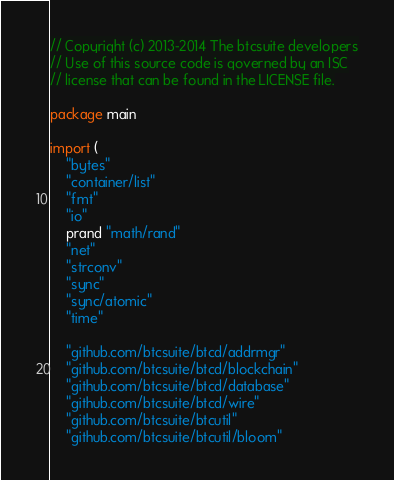Convert code to text. <code><loc_0><loc_0><loc_500><loc_500><_Go_>// Copyright (c) 2013-2014 The btcsuite developers
// Use of this source code is governed by an ISC
// license that can be found in the LICENSE file.

package main

import (
	"bytes"
	"container/list"
	"fmt"
	"io"
	prand "math/rand"
	"net"
	"strconv"
	"sync"
	"sync/atomic"
	"time"

	"github.com/btcsuite/btcd/addrmgr"
	"github.com/btcsuite/btcd/blockchain"
	"github.com/btcsuite/btcd/database"
	"github.com/btcsuite/btcd/wire"
	"github.com/btcsuite/btcutil"
	"github.com/btcsuite/btcutil/bloom"</code> 